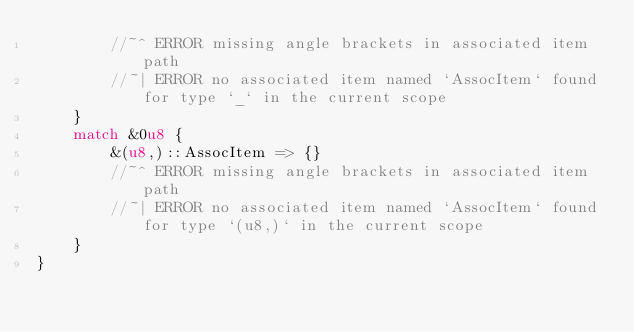<code> <loc_0><loc_0><loc_500><loc_500><_Rust_>        //~^ ERROR missing angle brackets in associated item path
        //~| ERROR no associated item named `AssocItem` found for type `_` in the current scope
    }
    match &0u8 {
        &(u8,)::AssocItem => {}
        //~^ ERROR missing angle brackets in associated item path
        //~| ERROR no associated item named `AssocItem` found for type `(u8,)` in the current scope
    }
}
</code> 